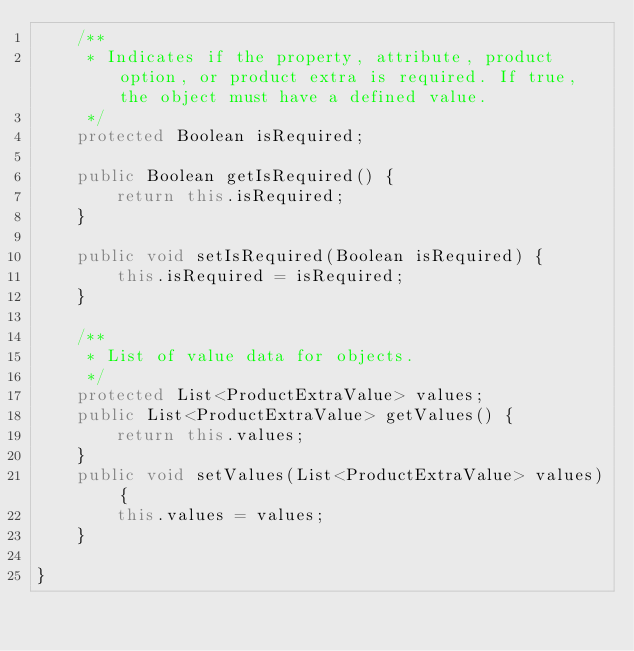<code> <loc_0><loc_0><loc_500><loc_500><_Java_>	/**
	 * Indicates if the property, attribute, product option, or product extra is required. If true, the object must have a defined value.
	 */
	protected Boolean isRequired;

	public Boolean getIsRequired() {
		return this.isRequired;
	}

	public void setIsRequired(Boolean isRequired) {
		this.isRequired = isRequired;
	}

	/**
	 * List of value data for objects.
	 */
	protected List<ProductExtraValue> values;
	public List<ProductExtraValue> getValues() {
		return this.values;
	}
	public void setValues(List<ProductExtraValue> values) {
		this.values = values;
	}

}
</code> 